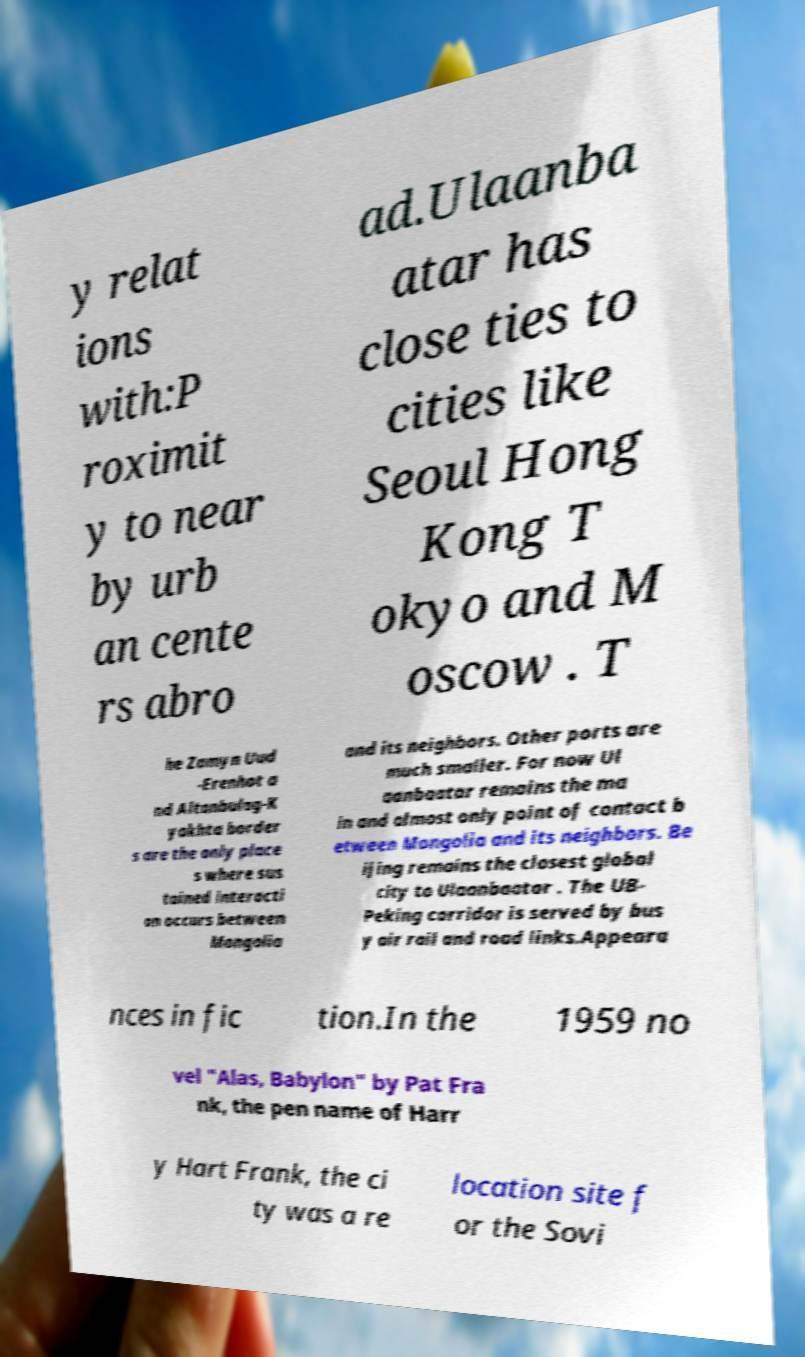Please read and relay the text visible in this image. What does it say? y relat ions with:P roximit y to near by urb an cente rs abro ad.Ulaanba atar has close ties to cities like Seoul Hong Kong T okyo and M oscow . T he Zamyn Uud -Erenhot a nd Altanbulag-K yakhta border s are the only place s where sus tained interacti on occurs between Mongolia and its neighbors. Other ports are much smaller. For now Ul aanbaatar remains the ma in and almost only point of contact b etween Mongolia and its neighbors. Be ijing remains the closest global city to Ulaanbaatar . The UB- Peking corridor is served by bus y air rail and road links.Appeara nces in fic tion.In the 1959 no vel "Alas, Babylon" by Pat Fra nk, the pen name of Harr y Hart Frank, the ci ty was a re location site f or the Sovi 